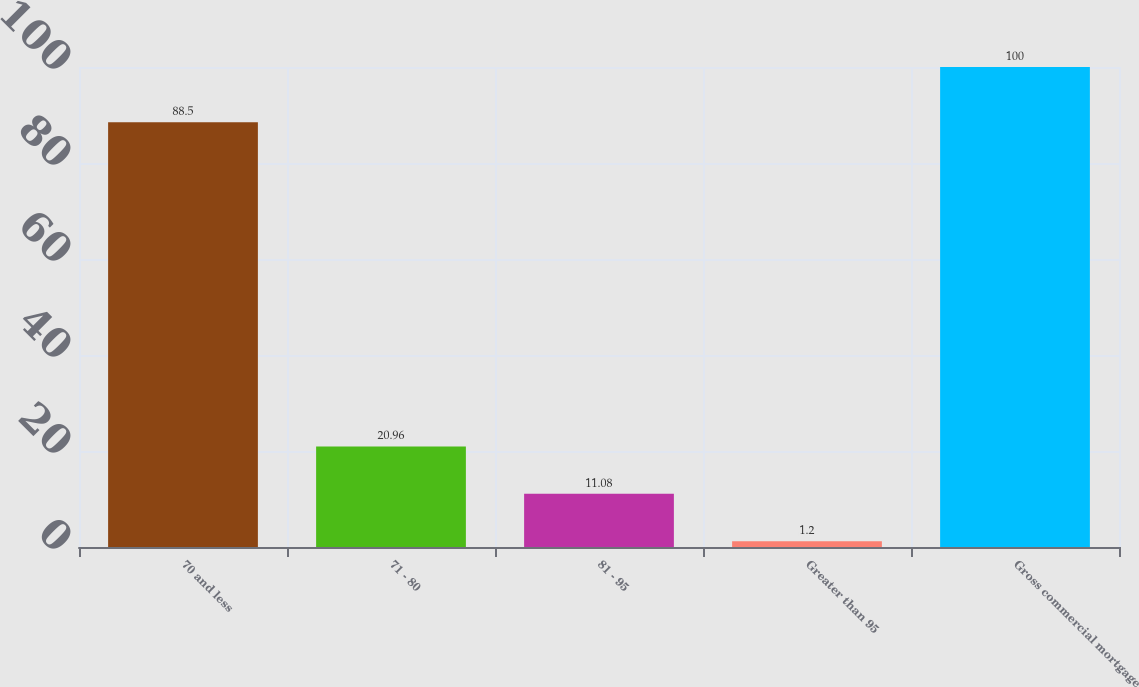Convert chart. <chart><loc_0><loc_0><loc_500><loc_500><bar_chart><fcel>70 and less<fcel>71 - 80<fcel>81 - 95<fcel>Greater than 95<fcel>Gross commercial mortgage<nl><fcel>88.5<fcel>20.96<fcel>11.08<fcel>1.2<fcel>100<nl></chart> 